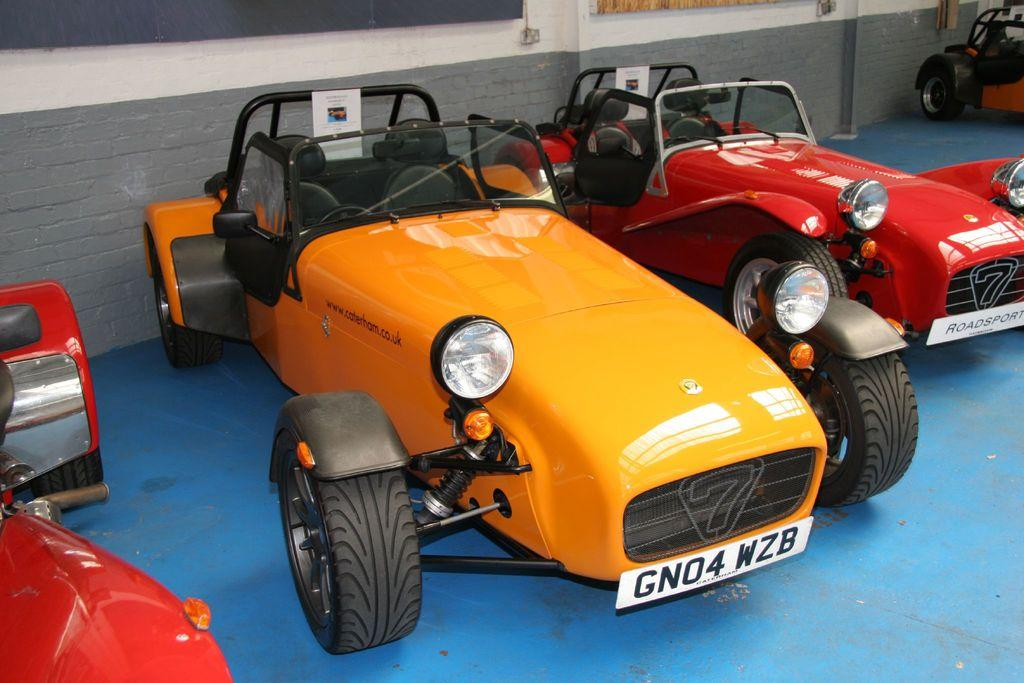What can be seen in the image? There are vehicles in the image. Where are the vehicles located? The vehicles are parked on a path. What is behind the vehicles? There is a wall behind the vehicles. What type of reaction can be seen from the vehicles in the image? Vehicles do not have reactions, as they are inanimate objects. 